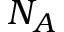<formula> <loc_0><loc_0><loc_500><loc_500>N _ { A }</formula> 